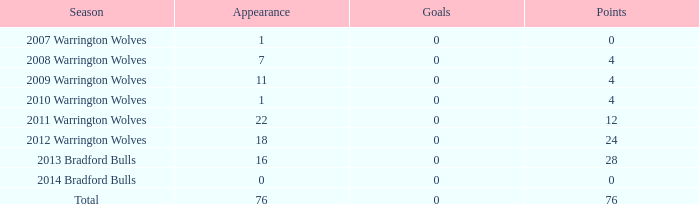What was the average number of tries for warrington wolves players with over 7 appearances in the 2008 season? None. 